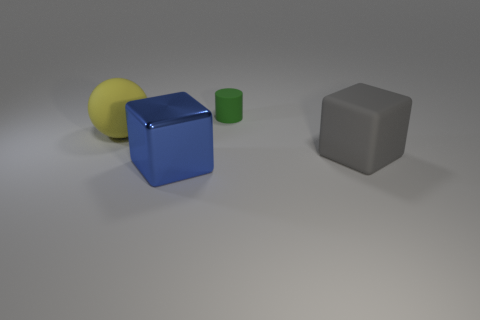Add 1 tiny green cylinders. How many objects exist? 5 Subtract all spheres. How many objects are left? 3 Subtract 0 red spheres. How many objects are left? 4 Subtract all red cylinders. Subtract all large yellow things. How many objects are left? 3 Add 3 big metal things. How many big metal things are left? 4 Add 1 big red spheres. How many big red spheres exist? 1 